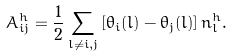<formula> <loc_0><loc_0><loc_500><loc_500>A _ { i j } ^ { h } = \frac { 1 } { 2 } \sum _ { l \neq i , j } \left [ \theta _ { i } ( l ) - \theta _ { j } ( l ) \right ] n _ { l } ^ { h } .</formula> 